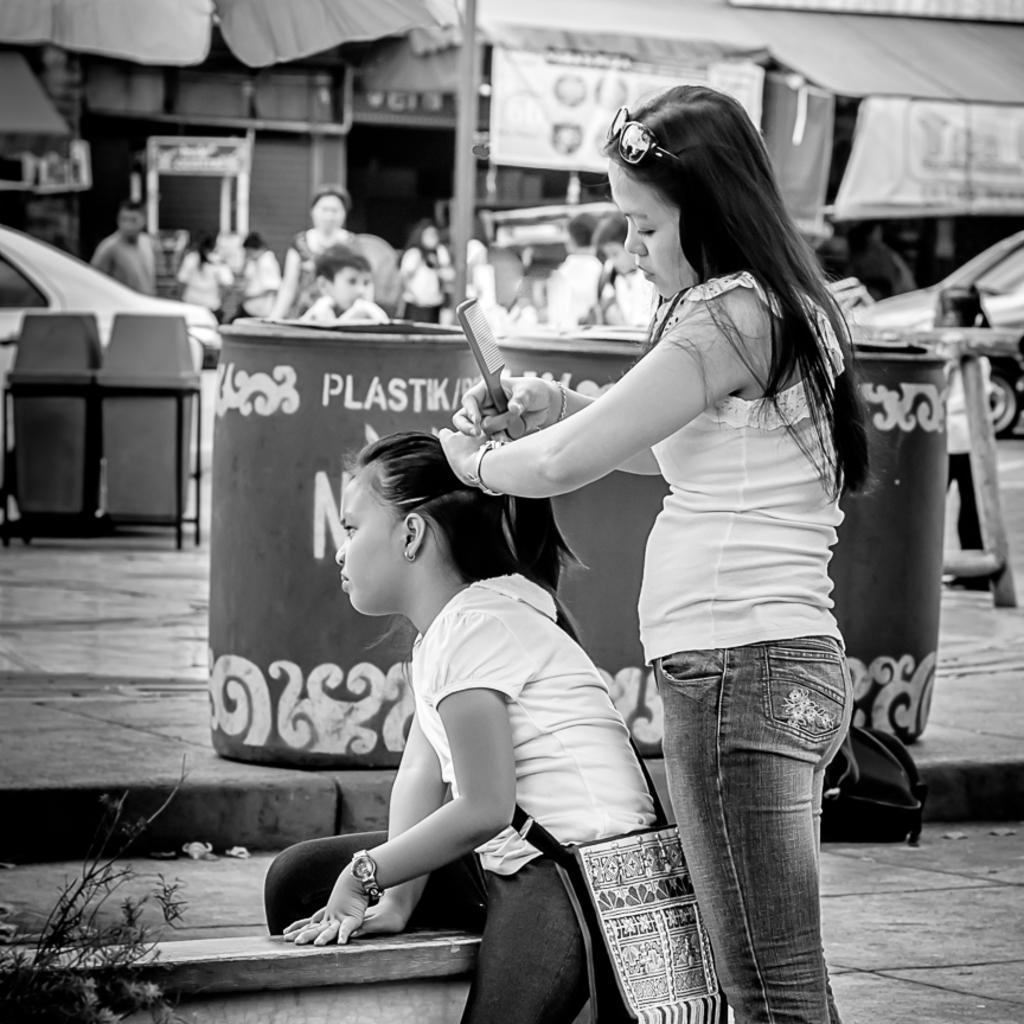Can you describe this image briefly? In the image we can see two women, one is standing and the other one is sitting, they are wearing clothes and a wrist watch. This is a goggle, comb and a handbag. This is a footpath, trash bin, plant, vehicle, pole, banner and the background are blurred. 